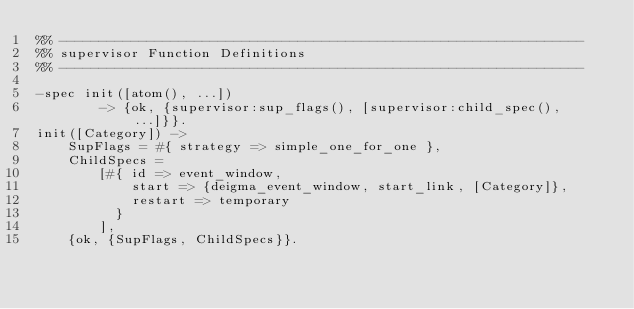Convert code to text. <code><loc_0><loc_0><loc_500><loc_500><_Erlang_>%% ------------------------------------------------------------------
%% supervisor Function Definitions
%% ------------------------------------------------------------------

-spec init([atom(), ...])
        -> {ok, {supervisor:sup_flags(), [supervisor:child_spec(), ...]}}.
init([Category]) ->
    SupFlags = #{ strategy => simple_one_for_one },
    ChildSpecs =
        [#{ id => event_window,
            start => {deigma_event_window, start_link, [Category]},
            restart => temporary
          }
        ],
    {ok, {SupFlags, ChildSpecs}}.
</code> 